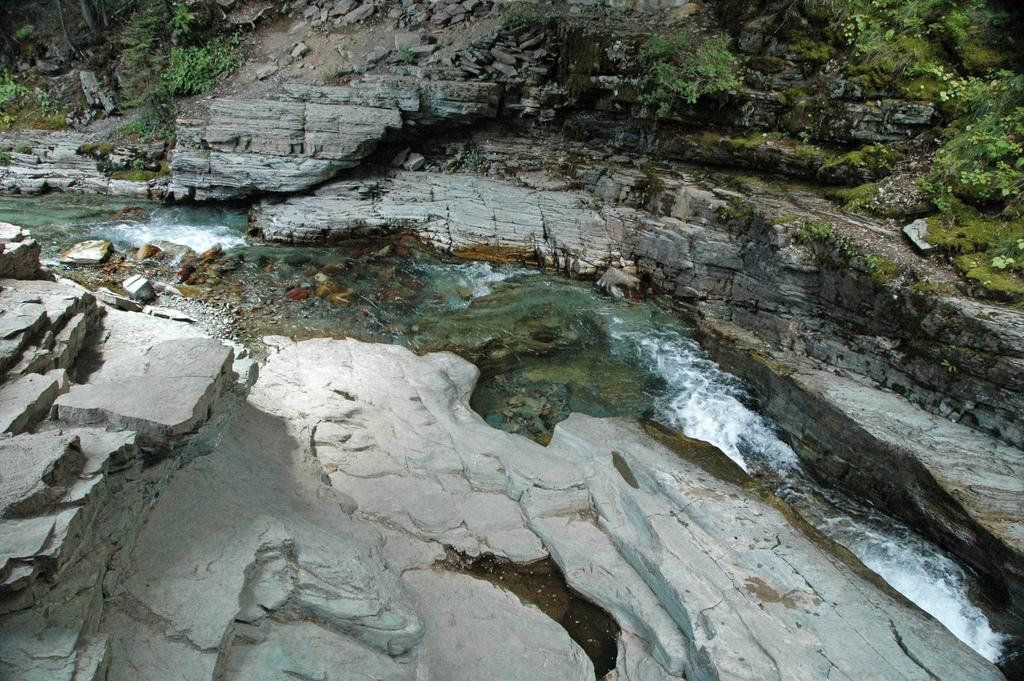What is the main feature in the middle of the image? There is a canal in the middle of the image. What surrounds the canal on either side? Huge rocks are on either side of the canal. What can be seen growing on the rocks? Plants are present on the rocks. What else can be observed on the rocks? Algae is visible on the rocks. Can you tell me how many strangers are walking around in their underwear near the canal? There is no mention of strangers or underwear in the image; it only features a canal, rocks, plants, and algae. 